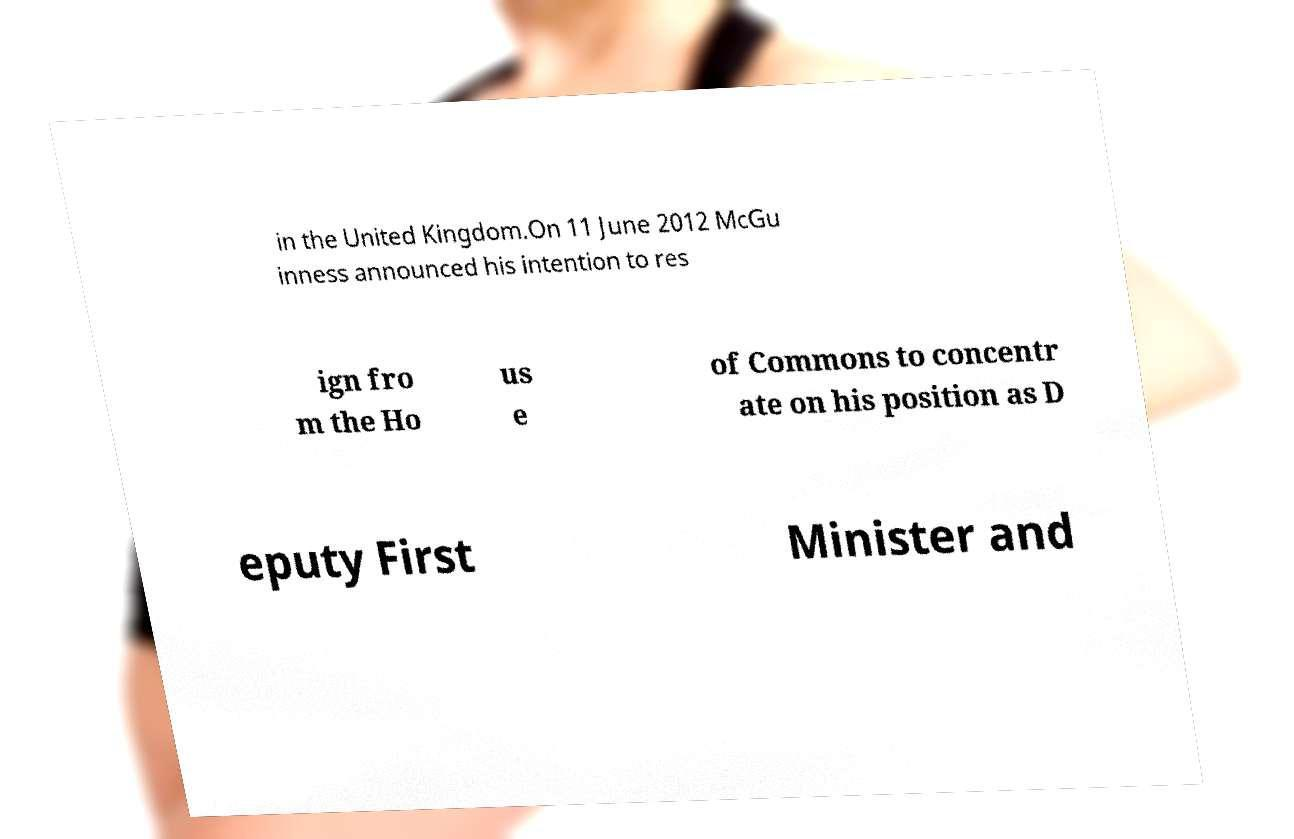Can you accurately transcribe the text from the provided image for me? in the United Kingdom.On 11 June 2012 McGu inness announced his intention to res ign fro m the Ho us e of Commons to concentr ate on his position as D eputy First Minister and 